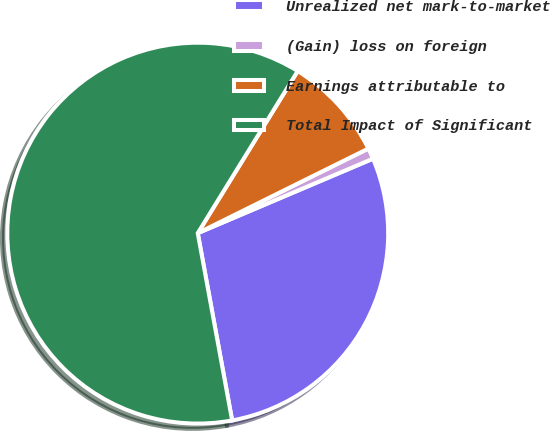Convert chart. <chart><loc_0><loc_0><loc_500><loc_500><pie_chart><fcel>Unrealized net mark-to-market<fcel>(Gain) loss on foreign<fcel>Earnings attributable to<fcel>Total Impact of Significant<nl><fcel>28.5%<fcel>0.93%<fcel>8.88%<fcel>61.68%<nl></chart> 